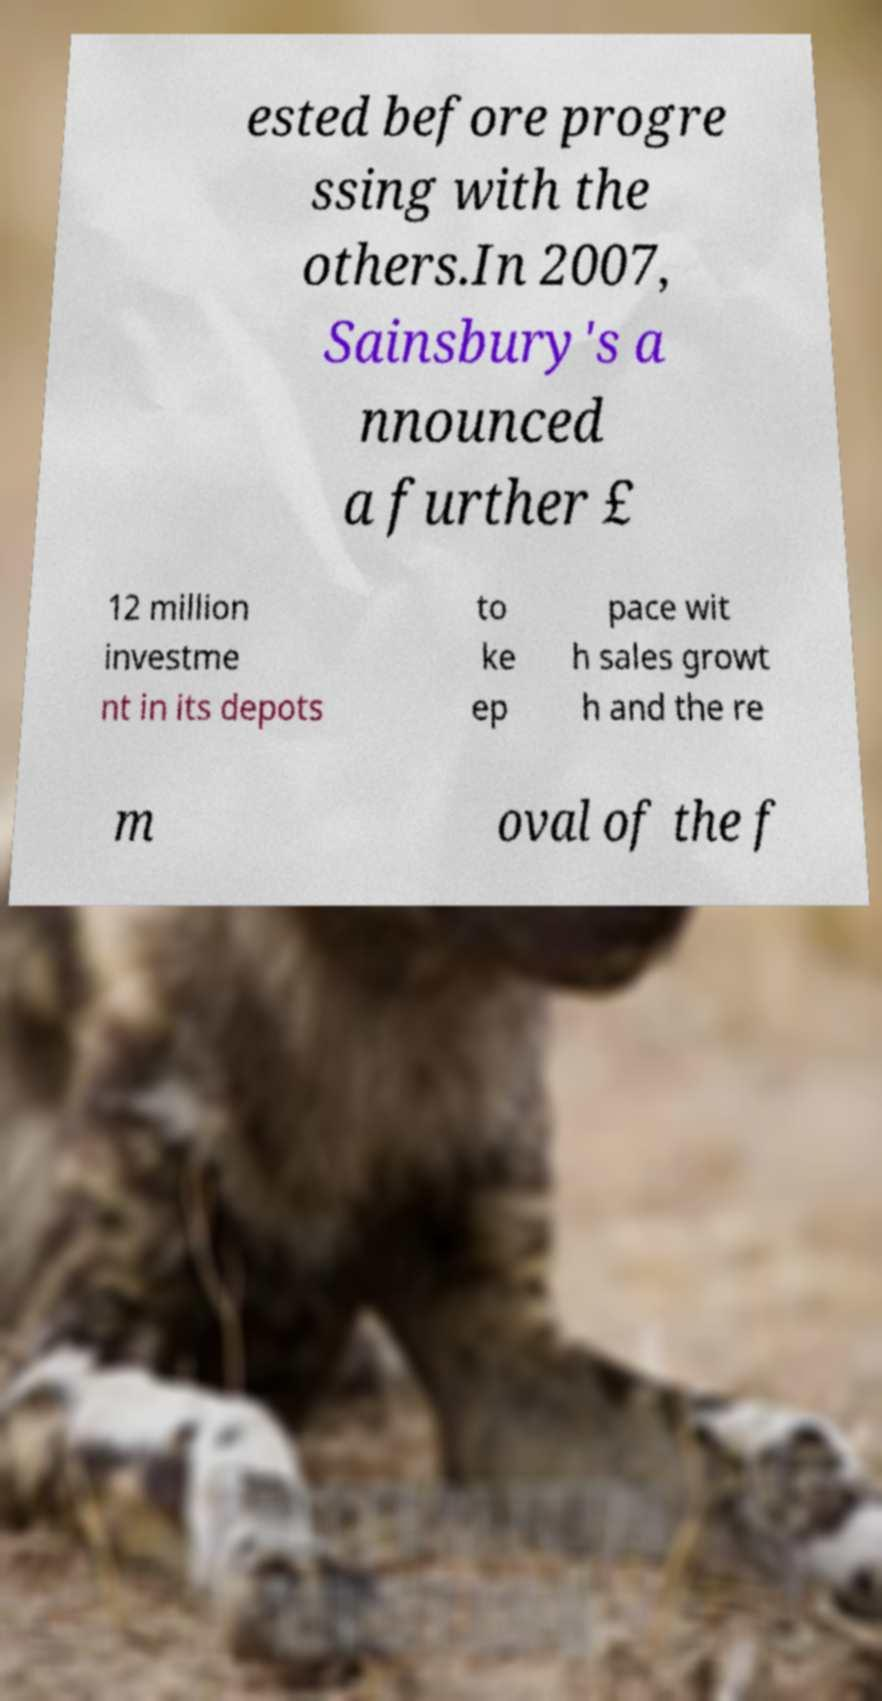Please read and relay the text visible in this image. What does it say? ested before progre ssing with the others.In 2007, Sainsbury's a nnounced a further £ 12 million investme nt in its depots to ke ep pace wit h sales growt h and the re m oval of the f 